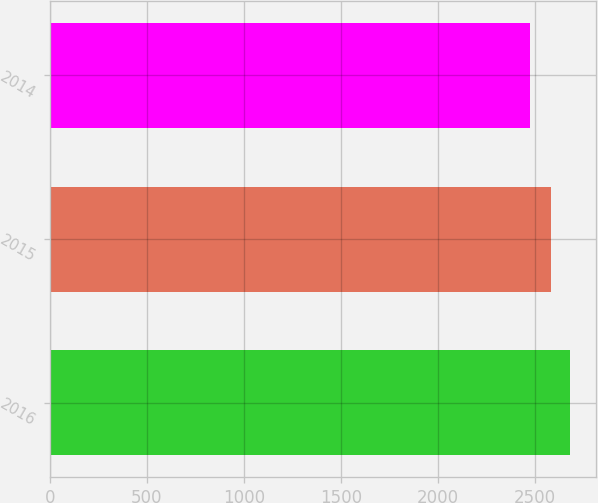Convert chart. <chart><loc_0><loc_0><loc_500><loc_500><bar_chart><fcel>2016<fcel>2015<fcel>2014<nl><fcel>2677.8<fcel>2581.6<fcel>2471.6<nl></chart> 